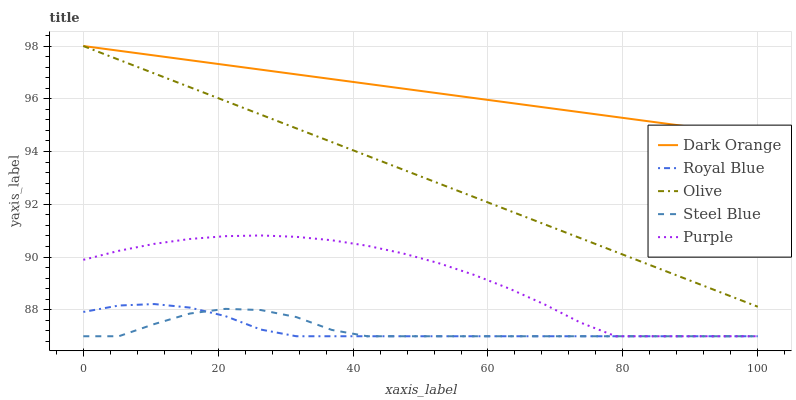Does Steel Blue have the minimum area under the curve?
Answer yes or no. Yes. Does Dark Orange have the maximum area under the curve?
Answer yes or no. Yes. Does Dark Orange have the minimum area under the curve?
Answer yes or no. No. Does Steel Blue have the maximum area under the curve?
Answer yes or no. No. Is Dark Orange the smoothest?
Answer yes or no. Yes. Is Steel Blue the roughest?
Answer yes or no. Yes. Is Steel Blue the smoothest?
Answer yes or no. No. Is Dark Orange the roughest?
Answer yes or no. No. Does Steel Blue have the lowest value?
Answer yes or no. Yes. Does Dark Orange have the lowest value?
Answer yes or no. No. Does Dark Orange have the highest value?
Answer yes or no. Yes. Does Steel Blue have the highest value?
Answer yes or no. No. Is Royal Blue less than Olive?
Answer yes or no. Yes. Is Dark Orange greater than Steel Blue?
Answer yes or no. Yes. Does Purple intersect Steel Blue?
Answer yes or no. Yes. Is Purple less than Steel Blue?
Answer yes or no. No. Is Purple greater than Steel Blue?
Answer yes or no. No. Does Royal Blue intersect Olive?
Answer yes or no. No. 